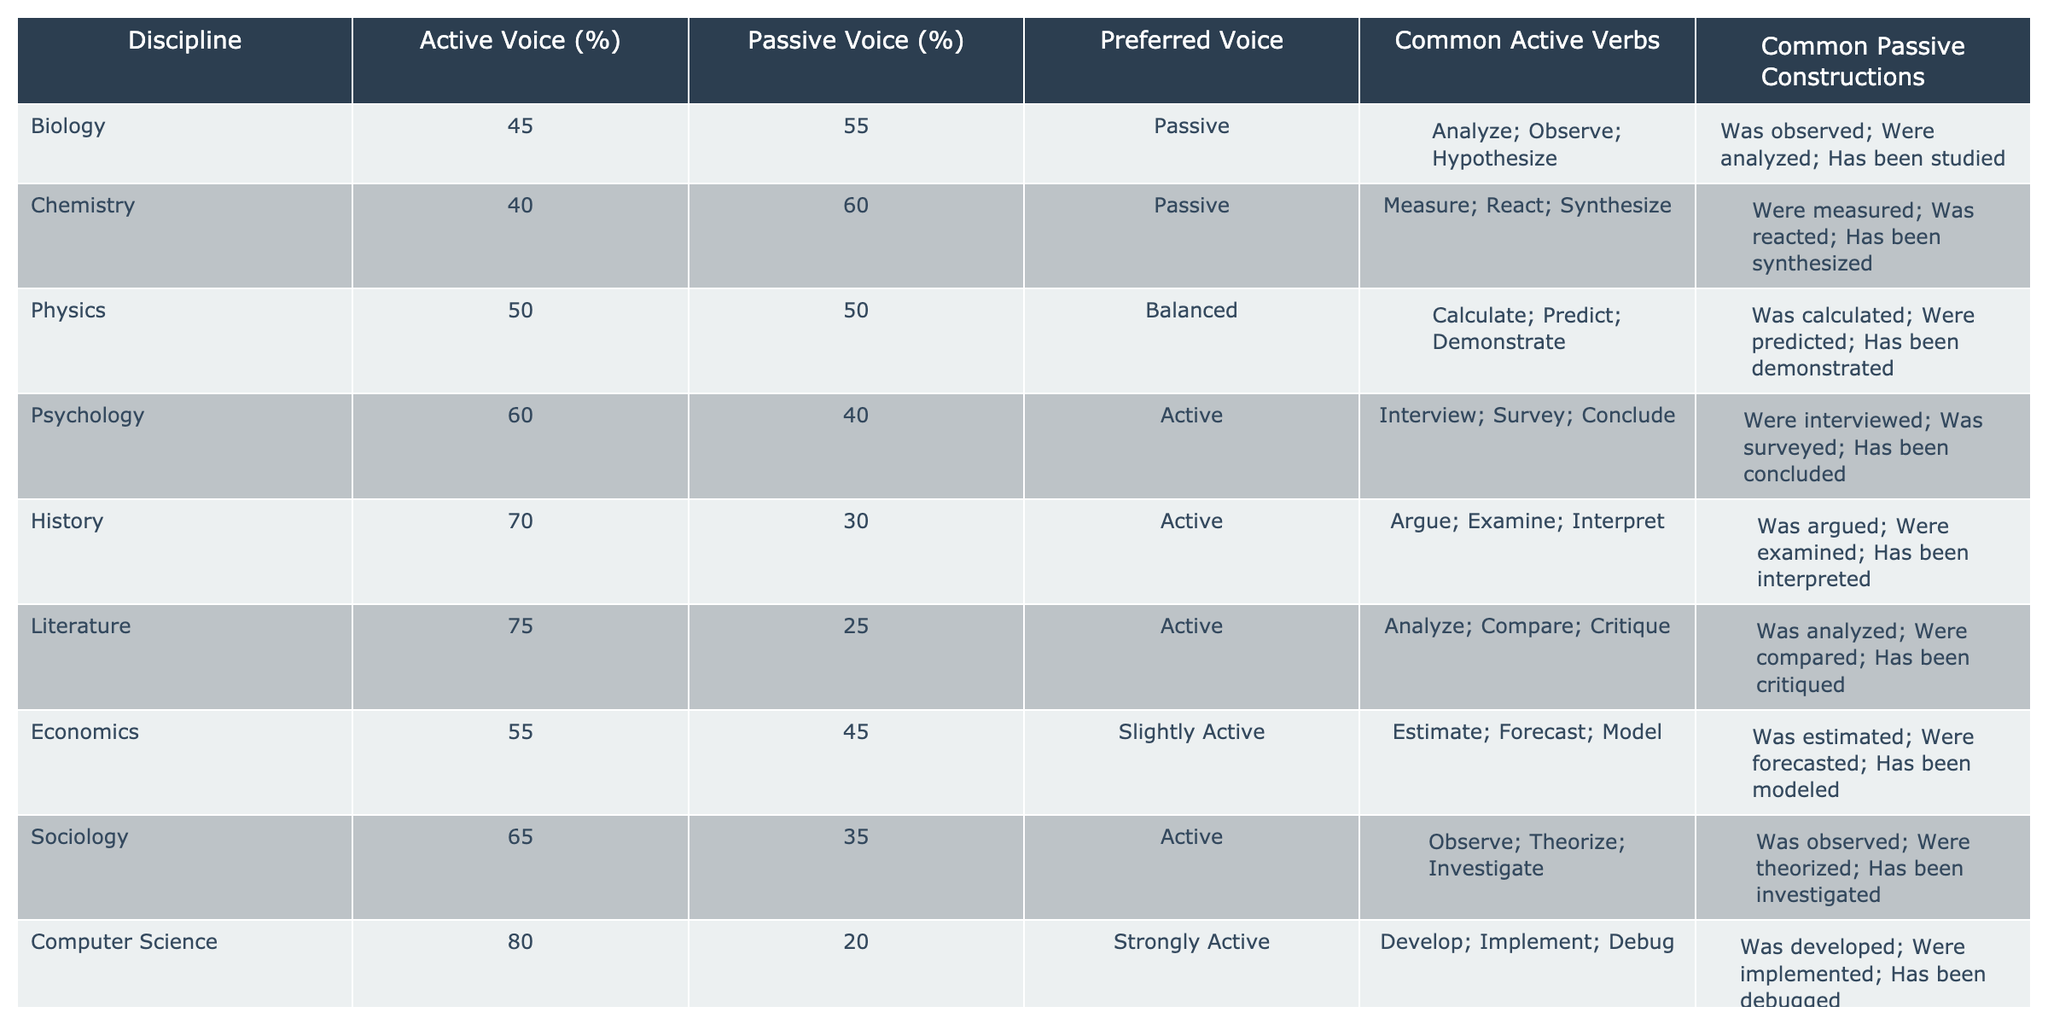What percentage of active voice is used in Biology? The table shows that Biology uses 45% active voice.
Answer: 45% Which discipline uses the highest percentage of passive voice? By looking at the table, Chemistry uses 60% passive voice, which is the highest among all the disciplines.
Answer: Chemistry What are the common active verbs used in Sociology? According to the table, the common active verbs in Sociology are Observe, Theorize, and Investigate.
Answer: Observe; Theorize; Investigate What is the difference in percentage between active and passive voice usage in Physics? The table indicates Physics uses 50% active and 50% passive voice. The difference is 50% - 50% = 0%.
Answer: 0% Is the preferred voice in Literature active? The table shows that Literature has a preferred voice of "Active". Therefore, the answer is yes.
Answer: Yes What is the average percentage of active voice usage across all disciplines? To find the average, sum the active voice percentages: 45 + 40 + 50 + 60 + 70 + 75 + 55 + 65 + 80 + 70 = 710. There are 10 disciplines, so the average is 710 / 10 = 71%.
Answer: 71% Which discipline shows a balanced preference between active and passive voice? The table states that Physics has 50% active and 50% passive voice, indicating a balanced preference.
Answer: Physics In which discipline is the passive construction "Has been studied" common? The table lists "Has been studied" as a common passive construction in Biology.
Answer: Biology Which discipline has a preferred voice that is "Slightly Active"? From the table, Economics is labeled as having a preferred voice of "Slightly Active."
Answer: Economics Which discipline has the lowest percentage of passive voice? The table indicates that Computer Science has the lowest percentage of passive voice at 20%.
Answer: Computer Science 